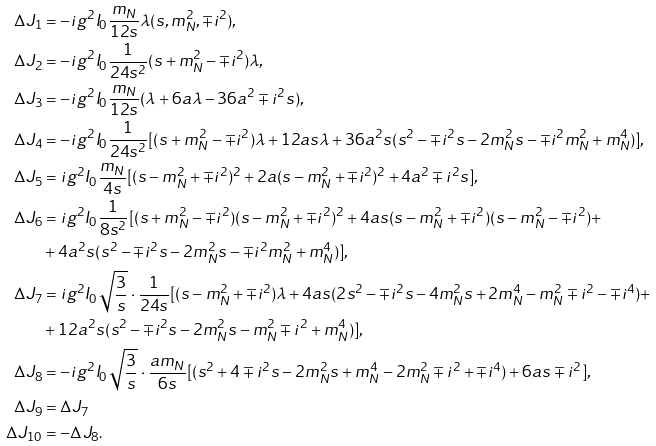Convert formula to latex. <formula><loc_0><loc_0><loc_500><loc_500>\Delta J _ { 1 } & = - i g ^ { 2 } I _ { 0 } \frac { m _ { N } } { 1 2 s } \lambda ( s , m _ { N } ^ { 2 } , \mp i ^ { 2 } ) , \\ \Delta J _ { 2 } & = - i g ^ { 2 } I _ { 0 } \frac { 1 } { 2 4 s ^ { 2 } } ( s + m _ { N } ^ { 2 } - \mp i ^ { 2 } ) \lambda , \\ \Delta J _ { 3 } & = - i g ^ { 2 } I _ { 0 } \frac { m _ { N } } { 1 2 s } ( \lambda + 6 a \lambda - 3 6 a ^ { 2 } \mp i ^ { 2 } s ) , \\ \Delta J _ { 4 } & = - i g ^ { 2 } I _ { 0 } \frac { 1 } { 2 4 s ^ { 2 } } [ ( s + m _ { N } ^ { 2 } - \mp i ^ { 2 } ) \lambda + 1 2 a s \lambda + 3 6 a ^ { 2 } s ( s ^ { 2 } - \mp i ^ { 2 } s - 2 m _ { N } ^ { 2 } s - \mp i ^ { 2 } m _ { N } ^ { 2 } + m _ { N } ^ { 4 } ) ] , \\ \Delta J _ { 5 } & = i g ^ { 2 } I _ { 0 } \frac { m _ { N } } { 4 s } [ ( s - m _ { N } ^ { 2 } + \mp i ^ { 2 } ) ^ { 2 } + 2 a ( s - m _ { N } ^ { 2 } + \mp i ^ { 2 } ) ^ { 2 } + 4 a ^ { 2 } \mp i ^ { 2 } s ] , \\ \Delta J _ { 6 } & = i g ^ { 2 } I _ { 0 } \frac { 1 } { 8 s ^ { 2 } } [ ( s + m _ { N } ^ { 2 } - \mp i ^ { 2 } ) ( s - m _ { N } ^ { 2 } + \mp i ^ { 2 } ) ^ { 2 } + 4 a s ( s - m _ { N } ^ { 2 } + \mp i ^ { 2 } ) ( s - m _ { N } ^ { 2 } - \mp i ^ { 2 } ) + \\ & + 4 a ^ { 2 } s ( s ^ { 2 } - \mp i ^ { 2 } s - 2 m _ { N } ^ { 2 } s - \mp i ^ { 2 } m _ { N } ^ { 2 } + m _ { N } ^ { 4 } ) ] , \\ \Delta J _ { 7 } & = i g ^ { 2 } I _ { 0 } \sqrt { \frac { 3 } { s } } \cdot \frac { 1 } { 2 4 s } [ ( s - m _ { N } ^ { 2 } + \mp i ^ { 2 } ) \lambda + 4 a s ( 2 s ^ { 2 } - \mp i ^ { 2 } s - 4 m _ { N } ^ { 2 } s + 2 m _ { N } ^ { 4 } - m _ { N } ^ { 2 } \mp i ^ { 2 } - \mp i ^ { 4 } ) + \\ & + 1 2 a ^ { 2 } s ( s ^ { 2 } - \mp i ^ { 2 } s - 2 m _ { N } ^ { 2 } s - m _ { N } ^ { 2 } \mp i ^ { 2 } + m _ { N } ^ { 4 } ) ] , \\ \Delta J _ { 8 } & = - i g ^ { 2 } I _ { 0 } \sqrt { \frac { 3 } { s } } \cdot \frac { a m _ { N } } { 6 s } [ ( s ^ { 2 } + 4 \mp i ^ { 2 } s - 2 m _ { N } ^ { 2 } s + m _ { N } ^ { 4 } - 2 m _ { N } ^ { 2 } \mp i ^ { 2 } + \mp i ^ { 4 } ) + 6 a s \mp i ^ { 2 } ] , \\ \Delta J _ { 9 } & = \Delta J _ { 7 } \\ \Delta J _ { 1 0 } & = - \Delta J _ { 8 } .</formula> 